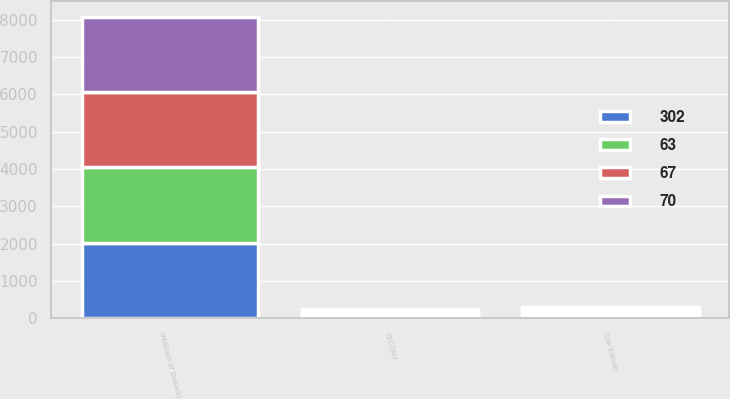Convert chart to OTSL. <chart><loc_0><loc_0><loc_500><loc_500><stacked_bar_chart><ecel><fcel>(Millions of Dollars)<fcel>Con Edison<fcel>CECONY<nl><fcel>70<fcel>2019<fcel>80<fcel>70<nl><fcel>67<fcel>2020<fcel>78<fcel>67<nl><fcel>63<fcel>2021<fcel>76<fcel>65<nl><fcel>302<fcel>2022<fcel>75<fcel>64<nl></chart> 